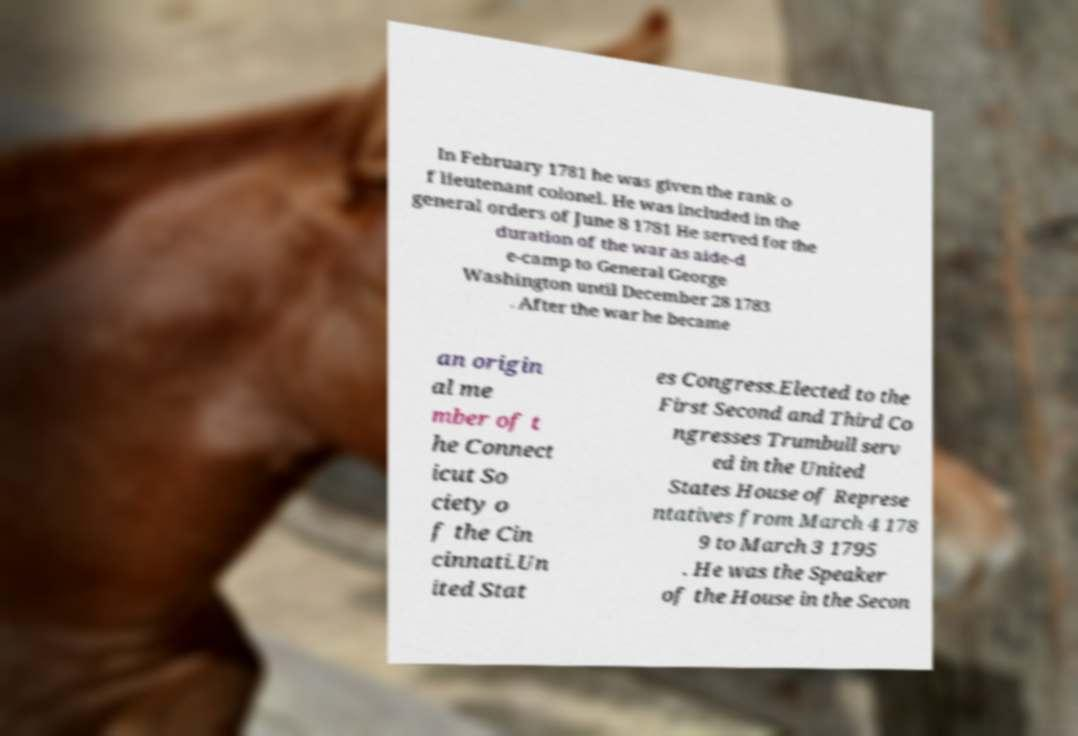Can you read and provide the text displayed in the image?This photo seems to have some interesting text. Can you extract and type it out for me? In February 1781 he was given the rank o f lieutenant colonel. He was included in the general orders of June 8 1781 He served for the duration of the war as aide-d e-camp to General George Washington until December 28 1783 . After the war he became an origin al me mber of t he Connect icut So ciety o f the Cin cinnati.Un ited Stat es Congress.Elected to the First Second and Third Co ngresses Trumbull serv ed in the United States House of Represe ntatives from March 4 178 9 to March 3 1795 . He was the Speaker of the House in the Secon 